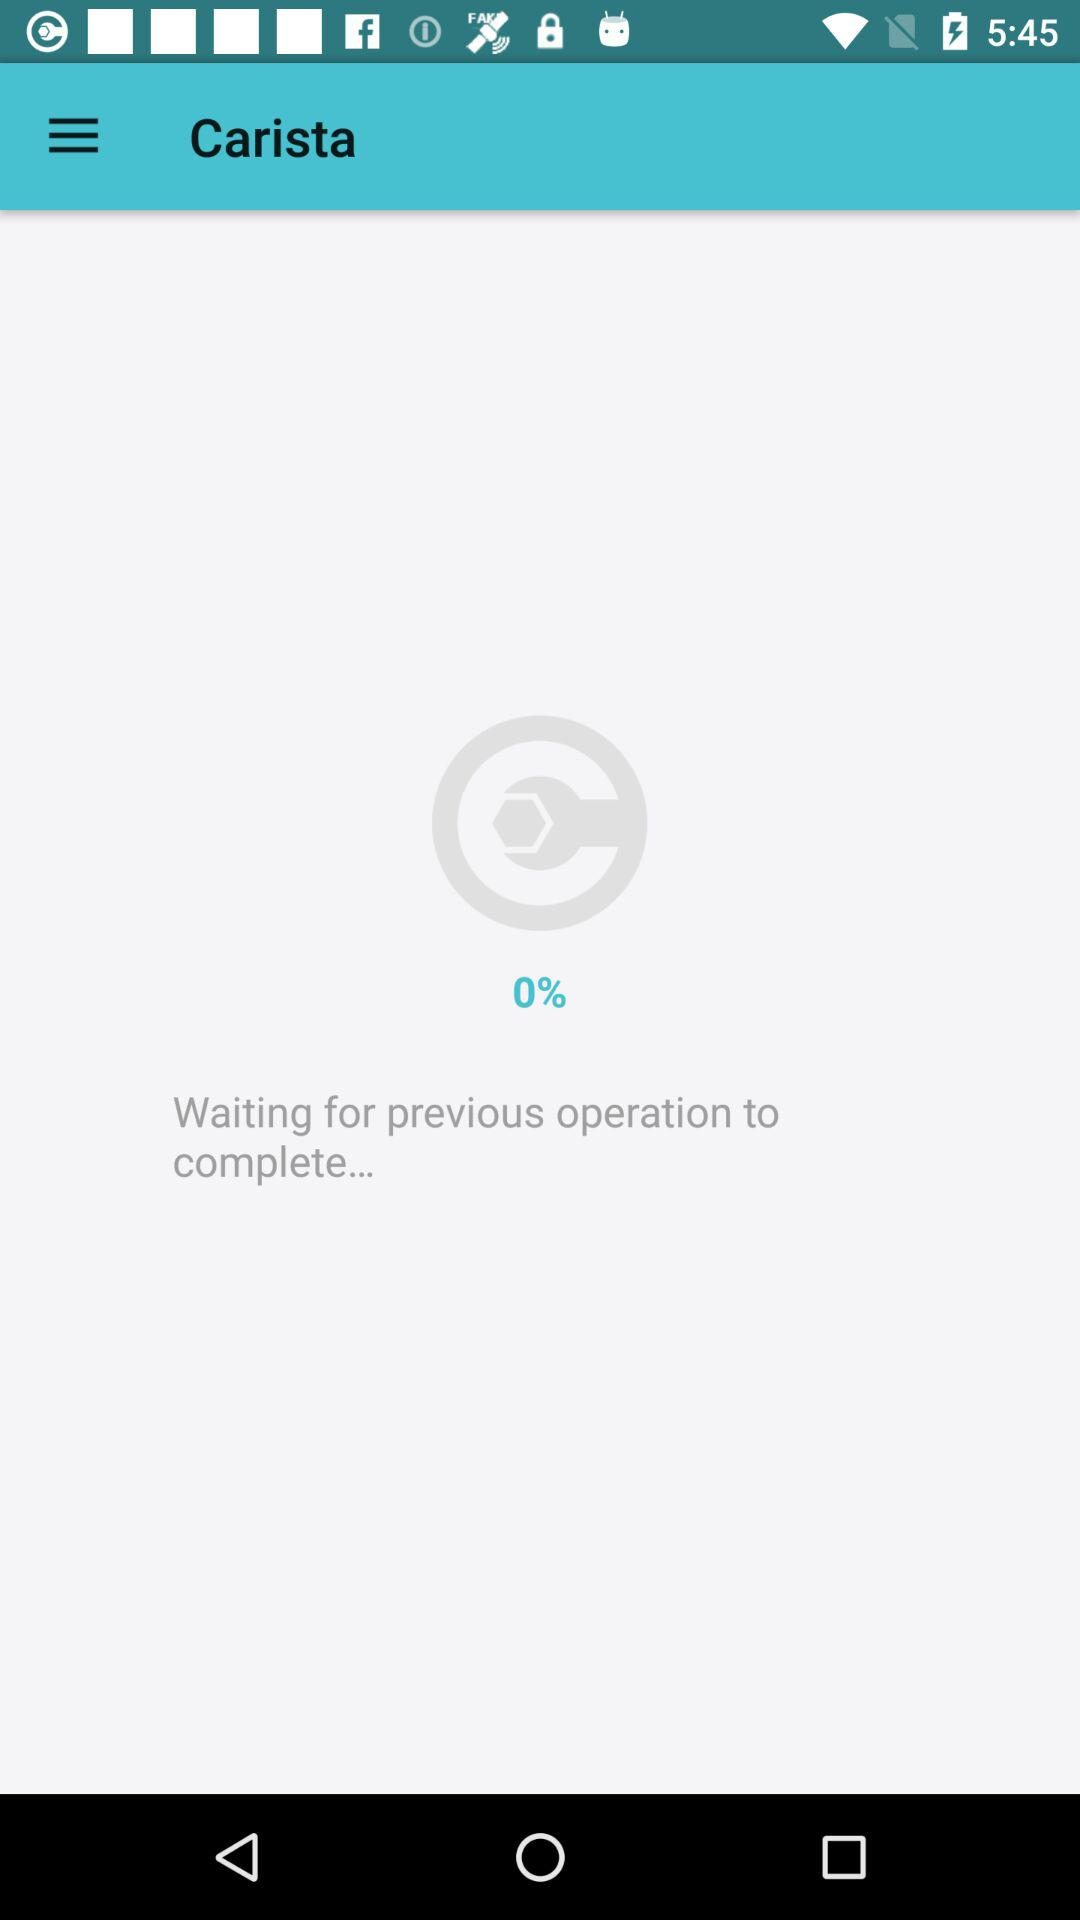What is the completion percentage of the previous operation? The completion percentage is 0. 